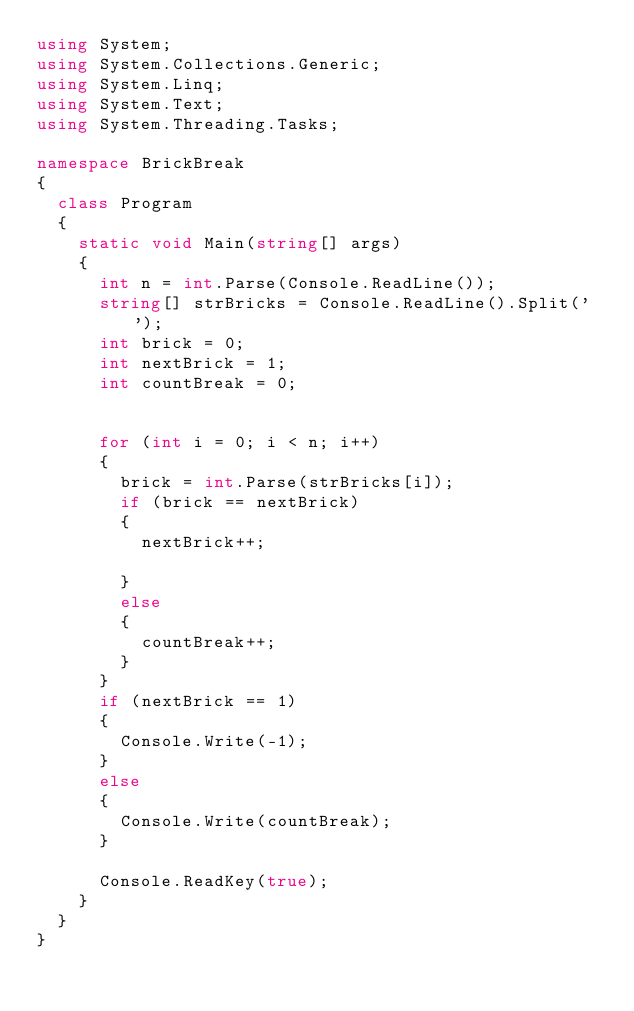<code> <loc_0><loc_0><loc_500><loc_500><_C#_>using System;
using System.Collections.Generic;
using System.Linq;
using System.Text;
using System.Threading.Tasks;

namespace BrickBreak
{
	class Program
	{
		static void Main(string[] args)
		{
			int n = int.Parse(Console.ReadLine());
			string[] strBricks = Console.ReadLine().Split(' ');
			int brick = 0;
			int nextBrick = 1;
			int countBreak = 0;


			for (int i = 0; i < n; i++)
			{
				brick = int.Parse(strBricks[i]);
				if (brick == nextBrick)
				{
					nextBrick++;
					
				}
				else
				{
					countBreak++;
				}
			}
			if (nextBrick == 1)
			{
				Console.Write(-1);
			}
			else
			{
				Console.Write(countBreak);
			}
			
			Console.ReadKey(true);
		}
	}
}
</code> 